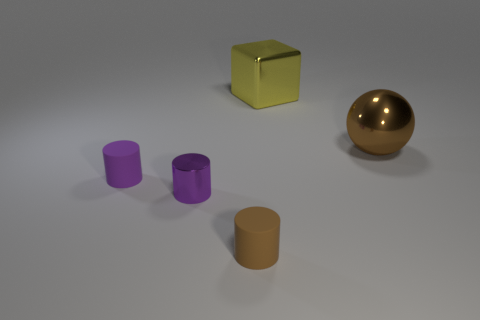Subtract all rubber cylinders. How many cylinders are left? 1 Subtract all brown cylinders. How many cylinders are left? 2 Add 5 small gray matte objects. How many objects exist? 10 Subtract all cylinders. How many objects are left? 2 Subtract all purple spheres. Subtract all green cylinders. How many spheres are left? 1 Add 2 metal cylinders. How many metal cylinders are left? 3 Add 4 big metallic spheres. How many big metallic spheres exist? 5 Subtract 0 gray blocks. How many objects are left? 5 Subtract 1 cylinders. How many cylinders are left? 2 Subtract all blue cubes. How many purple cylinders are left? 2 